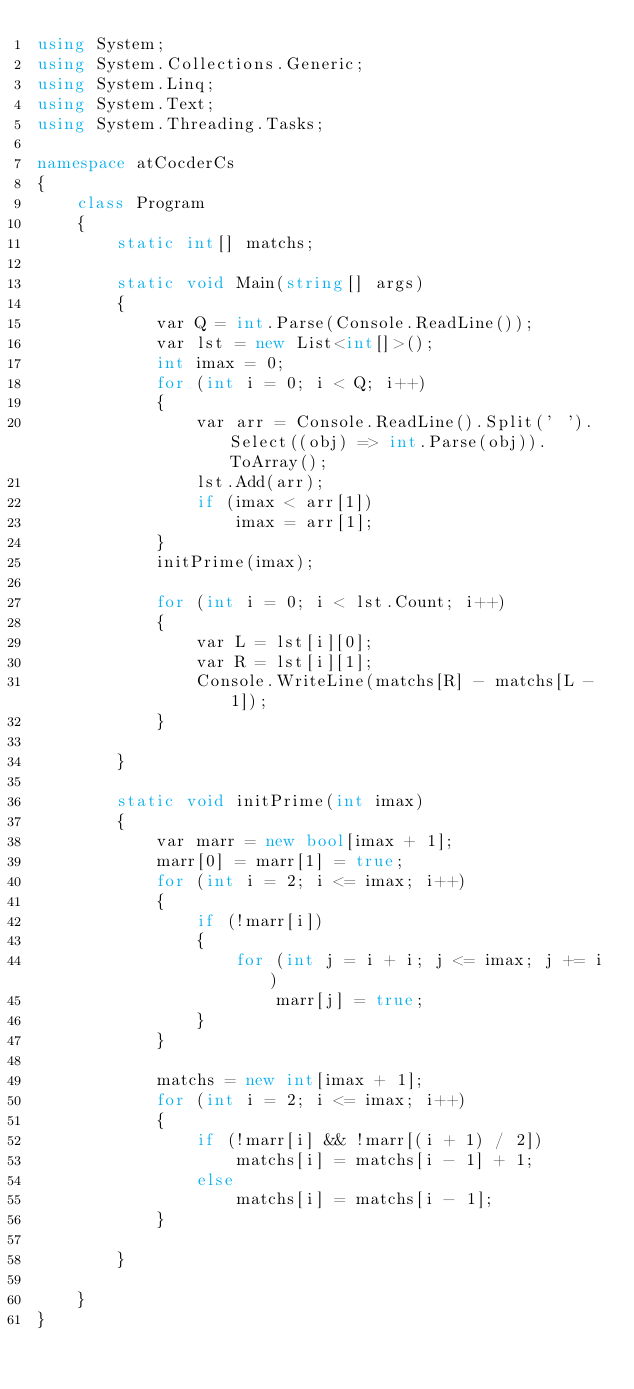<code> <loc_0><loc_0><loc_500><loc_500><_C#_>using System;
using System.Collections.Generic;
using System.Linq;
using System.Text;
using System.Threading.Tasks;

namespace atCocderCs
{
    class Program
    {
        static int[] matchs;

        static void Main(string[] args)
        {
            var Q = int.Parse(Console.ReadLine());
            var lst = new List<int[]>();
            int imax = 0;
            for (int i = 0; i < Q; i++)
            {
                var arr = Console.ReadLine().Split(' ').Select((obj) => int.Parse(obj)).ToArray();
                lst.Add(arr);
                if (imax < arr[1])
                    imax = arr[1];
            }
            initPrime(imax);

            for (int i = 0; i < lst.Count; i++)
            {
                var L = lst[i][0];
                var R = lst[i][1];
                Console.WriteLine(matchs[R] - matchs[L - 1]);
            }

        }

        static void initPrime(int imax)
        {
            var marr = new bool[imax + 1];
            marr[0] = marr[1] = true;
            for (int i = 2; i <= imax; i++)
            {
                if (!marr[i])
                {
                    for (int j = i + i; j <= imax; j += i)
                        marr[j] = true;
                }
            }

            matchs = new int[imax + 1];
            for (int i = 2; i <= imax; i++)
            {
                if (!marr[i] && !marr[(i + 1) / 2])
                    matchs[i] = matchs[i - 1] + 1;
                else
                    matchs[i] = matchs[i - 1];
            }

        }

    }
}
</code> 